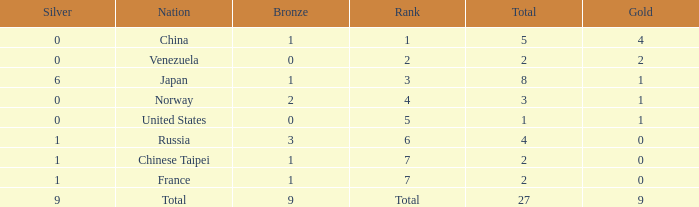What is the Nation when there is a total less than 27, gold is less than 1, and bronze is more than 1? Russia. 